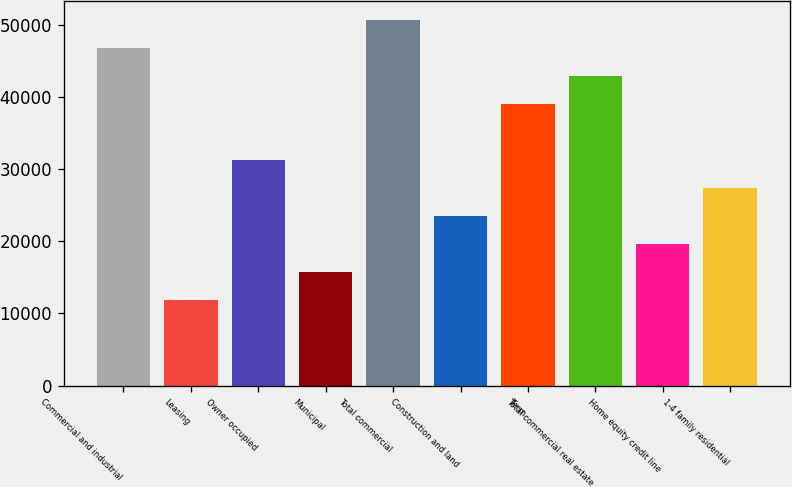Convert chart. <chart><loc_0><loc_0><loc_500><loc_500><bar_chart><fcel>Commercial and industrial<fcel>Leasing<fcel>Owner occupied<fcel>Municipal<fcel>Total commercial<fcel>Construction and land<fcel>Term<fcel>Total commercial real estate<fcel>Home equity credit line<fcel>1-4 family residential<nl><fcel>46810<fcel>11858.5<fcel>31276<fcel>15742<fcel>50693.5<fcel>23509<fcel>39043<fcel>42926.5<fcel>19625.5<fcel>27392.5<nl></chart> 